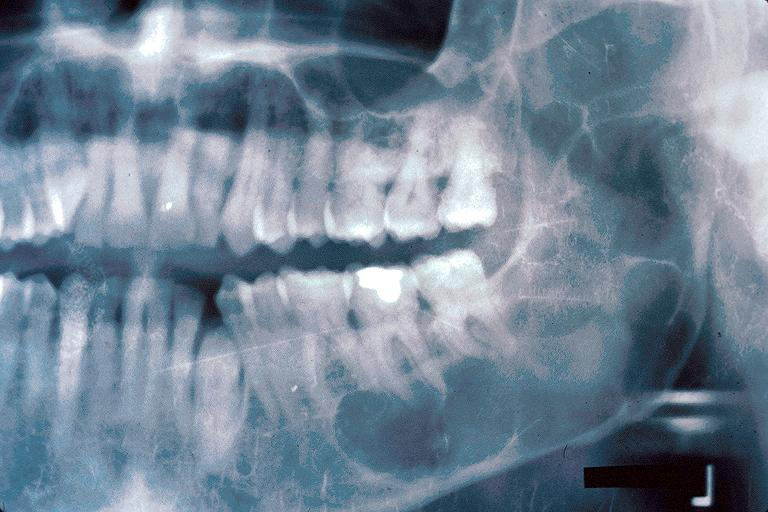does this image show odontogenic keratocyst?
Answer the question using a single word or phrase. Yes 